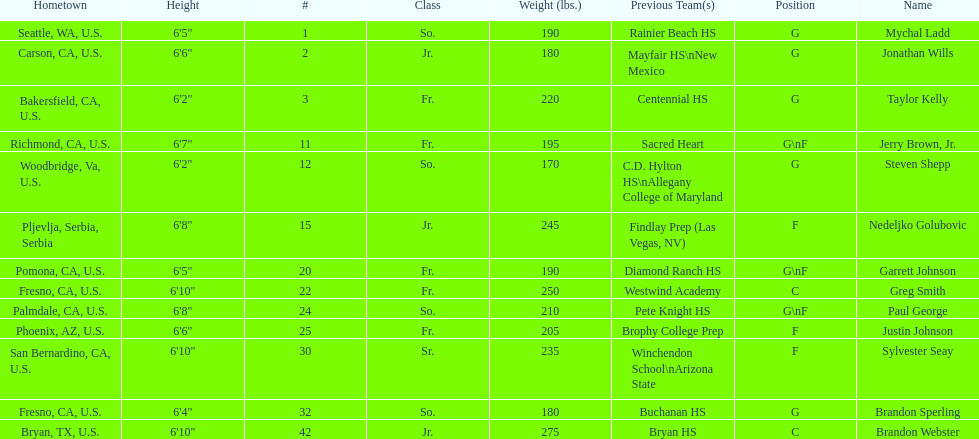Who is the next heaviest player after nedelijko golubovic? Sylvester Seay. 